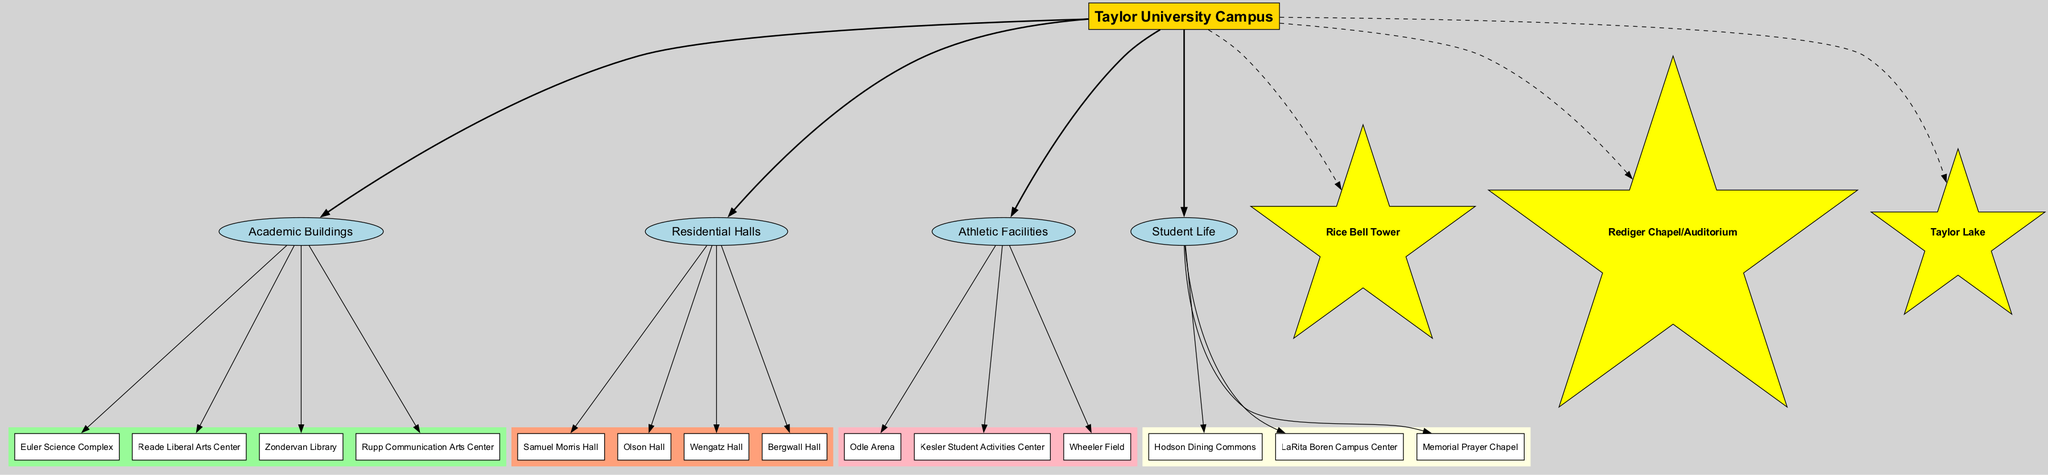What is the central node of the diagram? The central node is explicitly stated in the diagram as “Taylor University Campus.” Therefore, the answer is directly taken from the visual representation of the central theme.
Answer: Taylor University Campus How many academic buildings are present in the diagram? The academic buildings listed include Euler Science Complex, Reade Liberal Arts Center, Zondervan Library, and Rupp Communication Arts Center. Counting these, there are four academic buildings.
Answer: 4 Which building is part of the residential halls? The residential halls include Samuel Morris Hall, Olson Hall, Wengatz Hall, and Bergwall Hall. Any of these can be used to answer the question. For example, 'Samuel Morris Hall' is one of them.
Answer: Samuel Morris Hall What are the colors used for the main areas? The main areas are represented with different colors: Academic Buildings (palegreen), Residential Halls (lightsalmon), Athletic Facilities (lightpink), and Student Life (lightyellow). The answer requires listing these colors associated with each area.
Answer: palegreen, lightsalmon, lightpink, lightyellow Which facility is connected to the Odle Arena? The Odle Arena is classified under athletic facilities. To find its specific connection in the diagram, we can trace back to its main area and see that it connects to the 'Athletic Facilities' node, indicating its placement in that category.
Answer: Athletic Facilities 